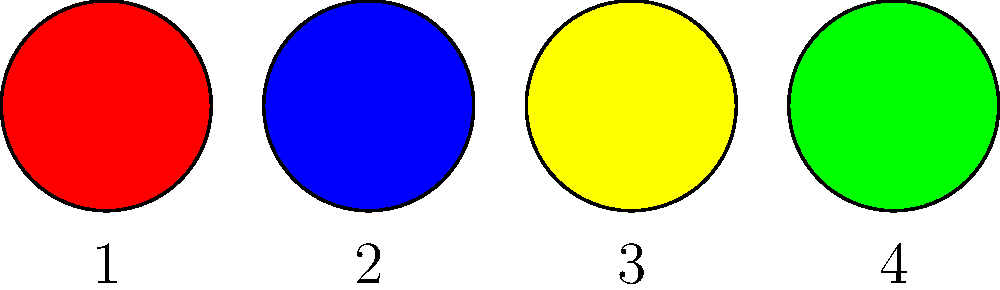In the series of abstract paintings above, which one would most likely evoke feelings of growth, harmony, and balance in the context of personal development? To answer this question, we need to consider the psychological effects of colors:

1. Red (Painting 1): Associated with energy, passion, and intensity. While it can stimulate personal growth, it's not typically associated with harmony and balance.

2. Blue (Painting 2): Often linked to calmness and trust. While it can promote reflection, it doesn't strongly evoke growth.

3. Yellow (Painting 3): Connected to optimism and creativity. It can stimulate mental activity but doesn't necessarily represent balance.

4. Green (Painting 4): Symbolizes growth, harmony, and balance in nature. In psychology, it's often associated with:
   a) Growth: Personal development and self-improvement
   b) Harmony: Emotional equilibrium and peace
   c) Balance: Mental well-being and stability

Given the context of personal development, the green painting (4) best represents the combination of growth, harmony, and balance.
Answer: Painting 4 (Green) 